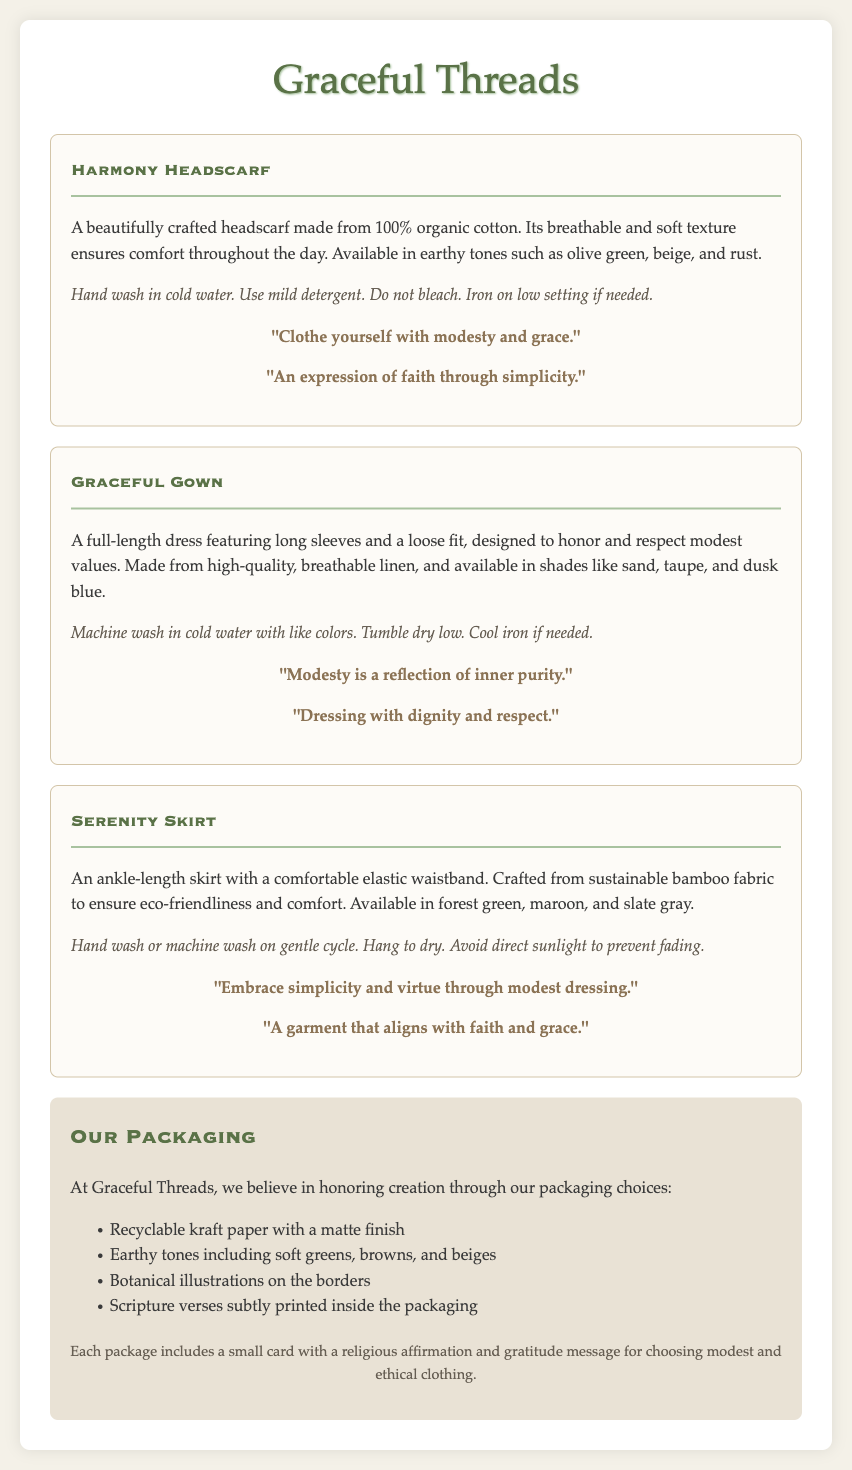What is the brand name? The brand name is prominently displayed at the top of the document as "Graceful Threads."
Answer: Graceful Threads How many garments are featured in the document? There are three different garments described in the document: Harmony Headscarf, Graceful Gown, and Serenity Skirt.
Answer: Three What material is the Harmony Headscarf made from? The document specifies that the Harmony Headscarf is made from "100% organic cotton."
Answer: 100% organic cotton What color is the Graceful Gown available in? The document lists the available shades of the Graceful Gown, which include sand, taupe, and dusk blue.
Answer: Sand, taupe, and dusk blue What type of packaging is used for Graceful Threads? The document mentions that they use "recyclable kraft paper with a matte finish."
Answer: Recyclable kraft paper with a matte finish What is one of the affirmations included with the Serenity Skirt? The document includes multiple affirmations; one of them is "Embrace simplicity and virtue through modest dressing."
Answer: Embrace simplicity and virtue through modest dressing What is the care instruction for the Serenity Skirt? The care instructions state: "Hand wash or machine wash on gentle cycle. Hang to dry."
Answer: Hand wash or machine wash on gentle cycle. Hang to dry What colors are available for the Serenity Skirt? The document lists forest green, maroon, and slate gray as the available colors for the Serenity Skirt.
Answer: Forest green, maroon, and slate gray What is included in each package? Each package includes "a small card with a religious affirmation and gratitude message."
Answer: A small card with a religious affirmation and gratitude message 